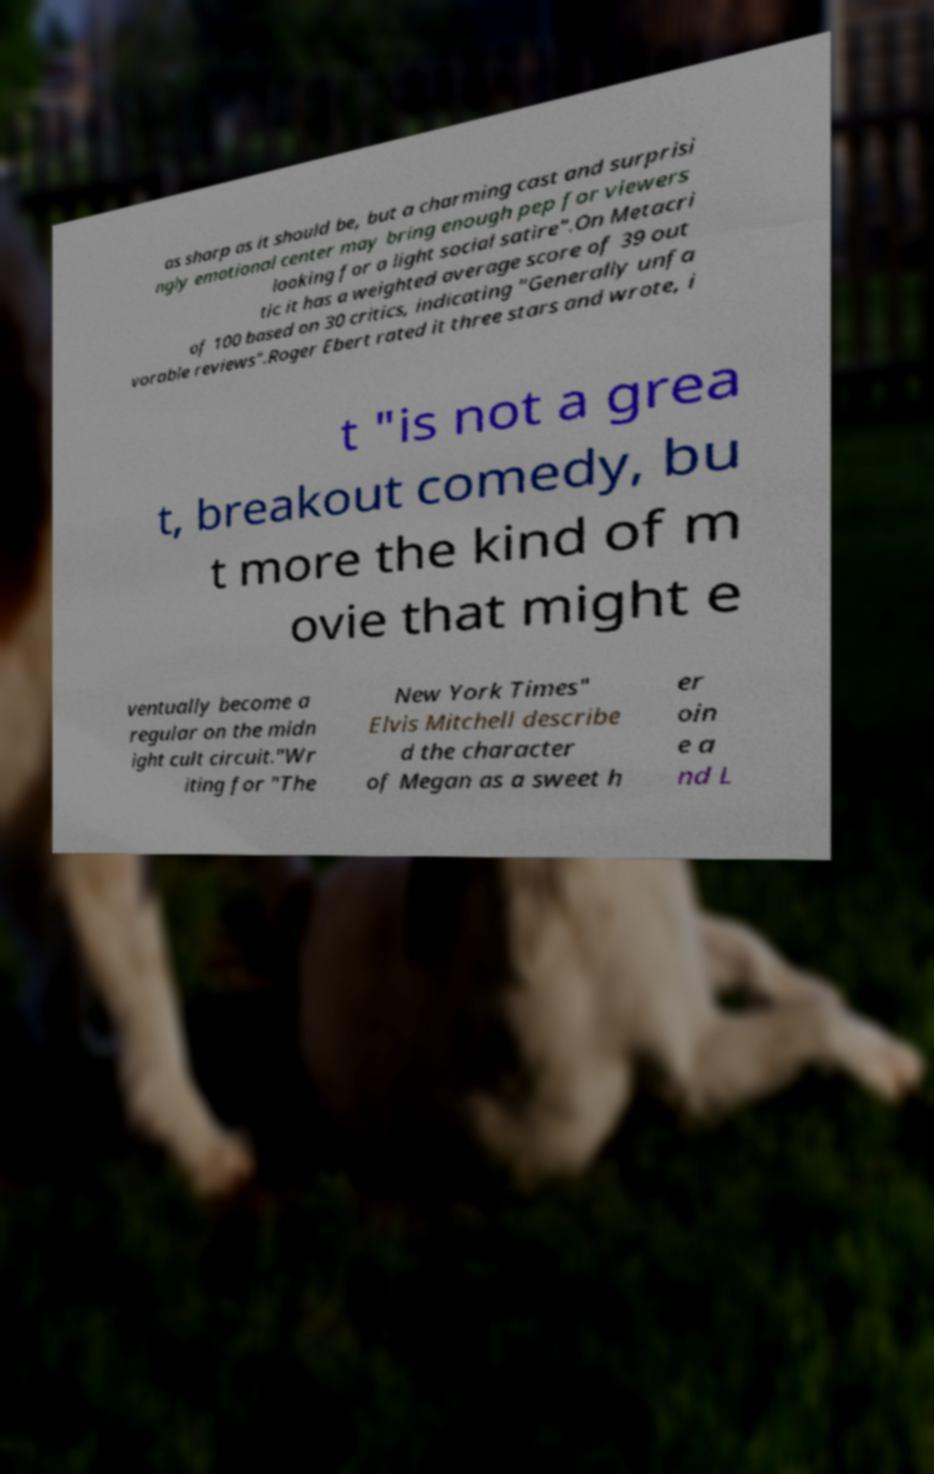Can you accurately transcribe the text from the provided image for me? as sharp as it should be, but a charming cast and surprisi ngly emotional center may bring enough pep for viewers looking for a light social satire".On Metacri tic it has a weighted average score of 39 out of 100 based on 30 critics, indicating "Generally unfa vorable reviews".Roger Ebert rated it three stars and wrote, i t "is not a grea t, breakout comedy, bu t more the kind of m ovie that might e ventually become a regular on the midn ight cult circuit."Wr iting for "The New York Times" Elvis Mitchell describe d the character of Megan as a sweet h er oin e a nd L 